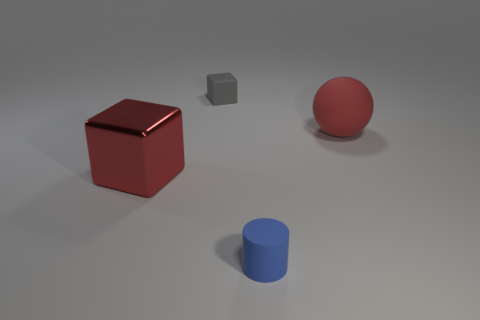Add 3 red metallic objects. How many objects exist? 7 Subtract all red cubes. How many cubes are left? 1 Subtract all cylinders. How many objects are left? 3 Subtract 1 cubes. How many cubes are left? 1 Subtract all brown balls. Subtract all red cylinders. How many balls are left? 1 Subtract all cyan cylinders. How many red cubes are left? 1 Subtract all red blocks. Subtract all red shiny objects. How many objects are left? 2 Add 1 red matte balls. How many red matte balls are left? 2 Add 3 rubber spheres. How many rubber spheres exist? 4 Subtract 0 blue spheres. How many objects are left? 4 